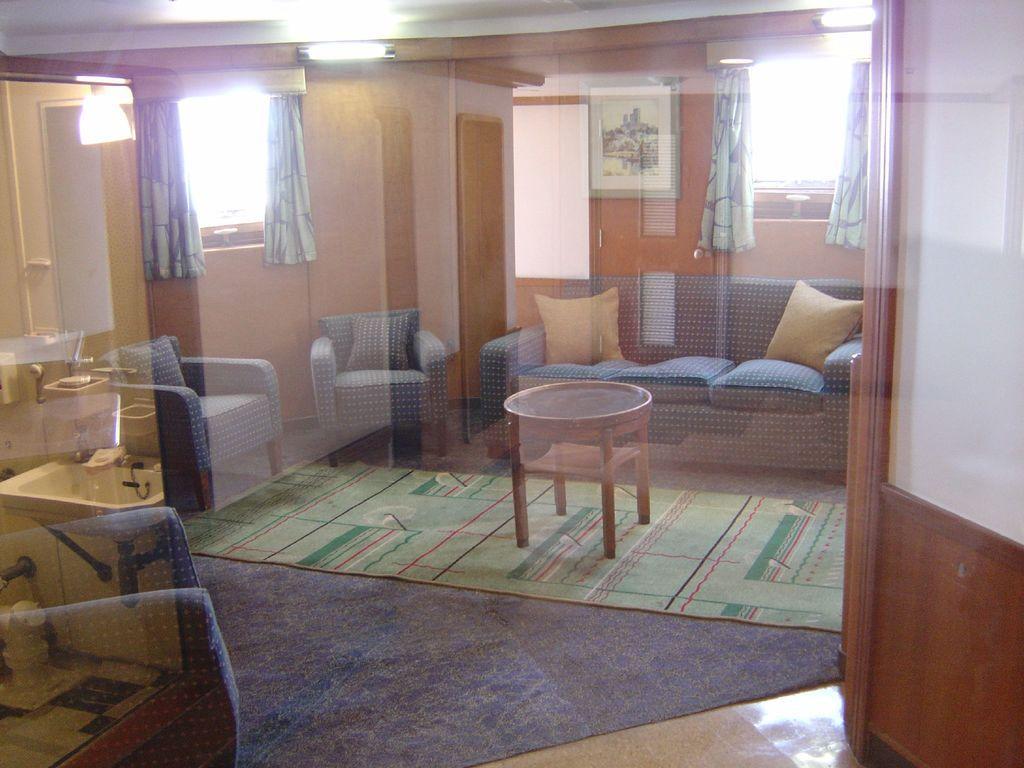Describe this image in one or two sentences. As we can see in the image there is a wall, window, curtain, sofas and pillows. 